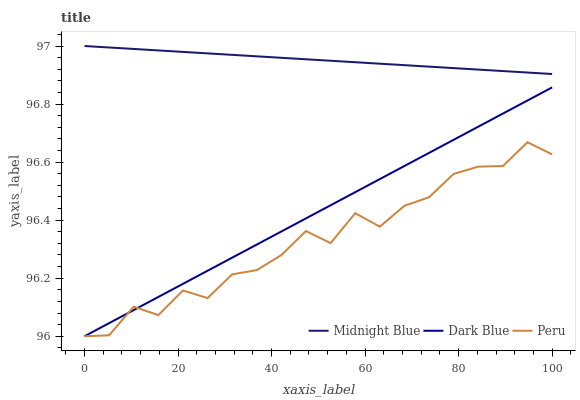Does Peru have the minimum area under the curve?
Answer yes or no. Yes. Does Midnight Blue have the maximum area under the curve?
Answer yes or no. Yes. Does Midnight Blue have the minimum area under the curve?
Answer yes or no. No. Does Peru have the maximum area under the curve?
Answer yes or no. No. Is Dark Blue the smoothest?
Answer yes or no. Yes. Is Peru the roughest?
Answer yes or no. Yes. Is Midnight Blue the smoothest?
Answer yes or no. No. Is Midnight Blue the roughest?
Answer yes or no. No. Does Dark Blue have the lowest value?
Answer yes or no. Yes. Does Midnight Blue have the lowest value?
Answer yes or no. No. Does Midnight Blue have the highest value?
Answer yes or no. Yes. Does Peru have the highest value?
Answer yes or no. No. Is Dark Blue less than Midnight Blue?
Answer yes or no. Yes. Is Midnight Blue greater than Peru?
Answer yes or no. Yes. Does Dark Blue intersect Peru?
Answer yes or no. Yes. Is Dark Blue less than Peru?
Answer yes or no. No. Is Dark Blue greater than Peru?
Answer yes or no. No. Does Dark Blue intersect Midnight Blue?
Answer yes or no. No. 